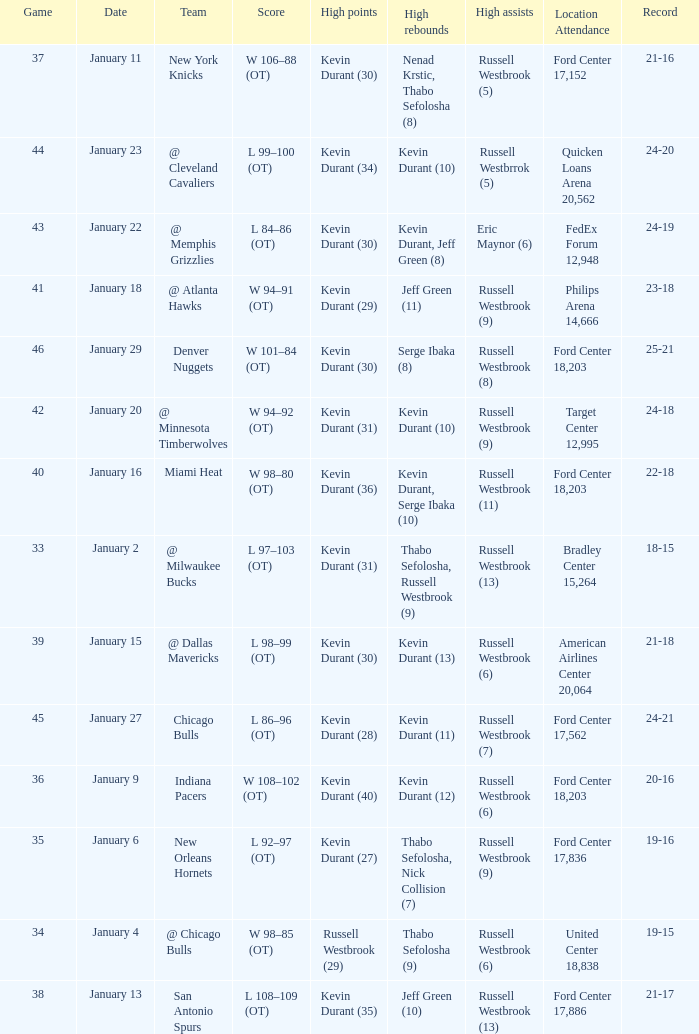Name the least game for january 29 46.0. Write the full table. {'header': ['Game', 'Date', 'Team', 'Score', 'High points', 'High rebounds', 'High assists', 'Location Attendance', 'Record'], 'rows': [['37', 'January 11', 'New York Knicks', 'W 106–88 (OT)', 'Kevin Durant (30)', 'Nenad Krstic, Thabo Sefolosha (8)', 'Russell Westbrook (5)', 'Ford Center 17,152', '21-16'], ['44', 'January 23', '@ Cleveland Cavaliers', 'L 99–100 (OT)', 'Kevin Durant (34)', 'Kevin Durant (10)', 'Russell Westbrrok (5)', 'Quicken Loans Arena 20,562', '24-20'], ['43', 'January 22', '@ Memphis Grizzlies', 'L 84–86 (OT)', 'Kevin Durant (30)', 'Kevin Durant, Jeff Green (8)', 'Eric Maynor (6)', 'FedEx Forum 12,948', '24-19'], ['41', 'January 18', '@ Atlanta Hawks', 'W 94–91 (OT)', 'Kevin Durant (29)', 'Jeff Green (11)', 'Russell Westbrook (9)', 'Philips Arena 14,666', '23-18'], ['46', 'January 29', 'Denver Nuggets', 'W 101–84 (OT)', 'Kevin Durant (30)', 'Serge Ibaka (8)', 'Russell Westbrook (8)', 'Ford Center 18,203', '25-21'], ['42', 'January 20', '@ Minnesota Timberwolves', 'W 94–92 (OT)', 'Kevin Durant (31)', 'Kevin Durant (10)', 'Russell Westbrook (9)', 'Target Center 12,995', '24-18'], ['40', 'January 16', 'Miami Heat', 'W 98–80 (OT)', 'Kevin Durant (36)', 'Kevin Durant, Serge Ibaka (10)', 'Russell Westbrook (11)', 'Ford Center 18,203', '22-18'], ['33', 'January 2', '@ Milwaukee Bucks', 'L 97–103 (OT)', 'Kevin Durant (31)', 'Thabo Sefolosha, Russell Westbrook (9)', 'Russell Westbrook (13)', 'Bradley Center 15,264', '18-15'], ['39', 'January 15', '@ Dallas Mavericks', 'L 98–99 (OT)', 'Kevin Durant (30)', 'Kevin Durant (13)', 'Russell Westbrook (6)', 'American Airlines Center 20,064', '21-18'], ['45', 'January 27', 'Chicago Bulls', 'L 86–96 (OT)', 'Kevin Durant (28)', 'Kevin Durant (11)', 'Russell Westbrook (7)', 'Ford Center 17,562', '24-21'], ['36', 'January 9', 'Indiana Pacers', 'W 108–102 (OT)', 'Kevin Durant (40)', 'Kevin Durant (12)', 'Russell Westbrook (6)', 'Ford Center 18,203', '20-16'], ['35', 'January 6', 'New Orleans Hornets', 'L 92–97 (OT)', 'Kevin Durant (27)', 'Thabo Sefolosha, Nick Collision (7)', 'Russell Westbrook (9)', 'Ford Center 17,836', '19-16'], ['34', 'January 4', '@ Chicago Bulls', 'W 98–85 (OT)', 'Russell Westbrook (29)', 'Thabo Sefolosha (9)', 'Russell Westbrook (6)', 'United Center 18,838', '19-15'], ['38', 'January 13', 'San Antonio Spurs', 'L 108–109 (OT)', 'Kevin Durant (35)', 'Jeff Green (10)', 'Russell Westbrook (13)', 'Ford Center 17,886', '21-17']]} 